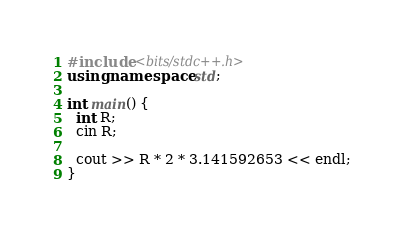<code> <loc_0><loc_0><loc_500><loc_500><_C++_>#include <bits/stdc++.h>
using namespace std;

int main() {
  int R;
  cin R;
  
  cout >> R * 2 * 3.141592653 << endl;
}
</code> 